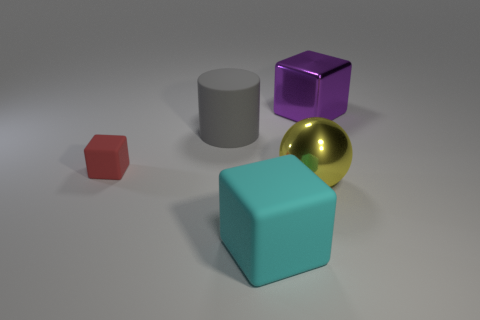Is the number of cylinders that are in front of the yellow metal thing less than the number of tiny blue metallic cubes?
Your answer should be compact. No. There is a big matte object in front of the large rubber object that is left of the large cube that is in front of the large purple block; what is its shape?
Offer a very short reply. Cube. What is the size of the rubber cube right of the small red object?
Make the answer very short. Large. The yellow shiny thing that is the same size as the cyan matte cube is what shape?
Your response must be concise. Sphere. What number of things are either large yellow metallic things or large objects that are to the right of the yellow metallic sphere?
Make the answer very short. 2. What number of rubber things are in front of the shiny object in front of the matte cube left of the large matte cube?
Provide a short and direct response. 1. There is a small cube that is made of the same material as the cyan object; what color is it?
Offer a terse response. Red. Do the object that is behind the gray rubber cylinder and the sphere have the same size?
Offer a terse response. Yes. What number of things are large gray matte things or red rubber objects?
Ensure brevity in your answer.  2. What material is the big cyan thing in front of the large cube that is on the right side of the big block in front of the small matte block made of?
Your answer should be compact. Rubber. 